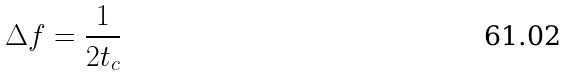Convert formula to latex. <formula><loc_0><loc_0><loc_500><loc_500>\Delta f = \frac { 1 } { 2 t _ { c } }</formula> 